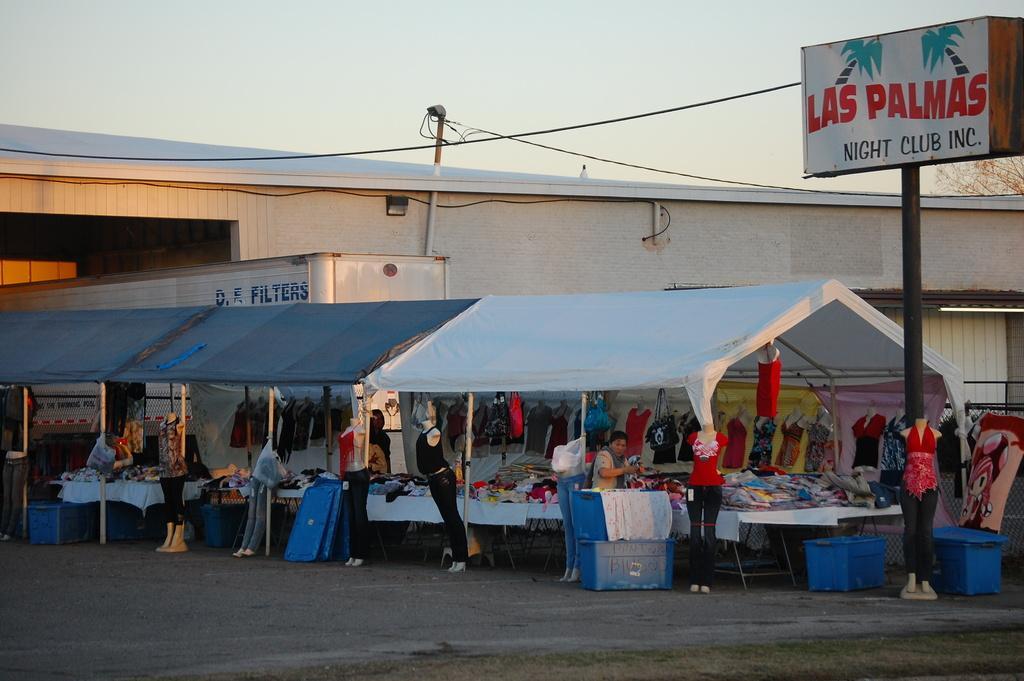Please provide a concise description of this image. In the picture I can see people and mannequin. I can so see building, stalls, clothes and a board with something written on it. In the background I can see a tree, wires and the sky. 